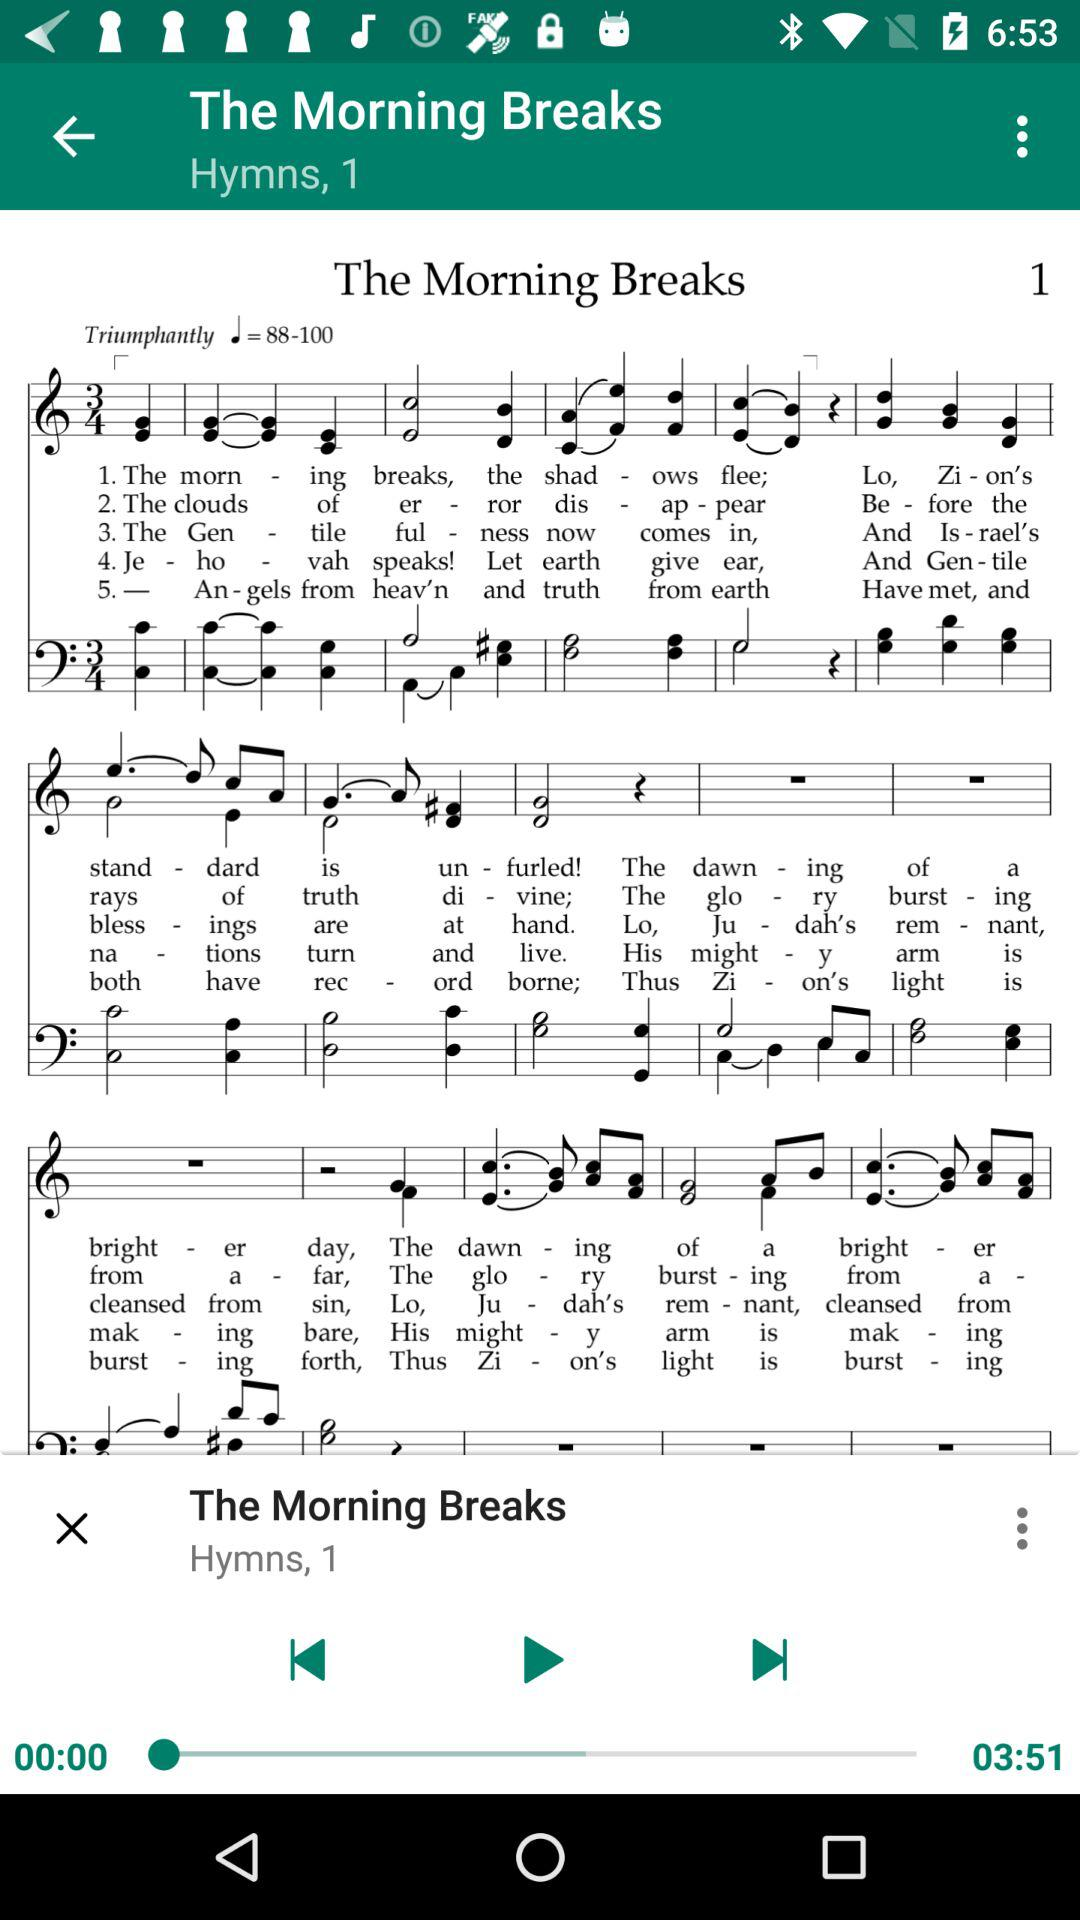What is the time duration of "Hymns, 1"? The time duration of "Hymns, 1" is 03:51. 